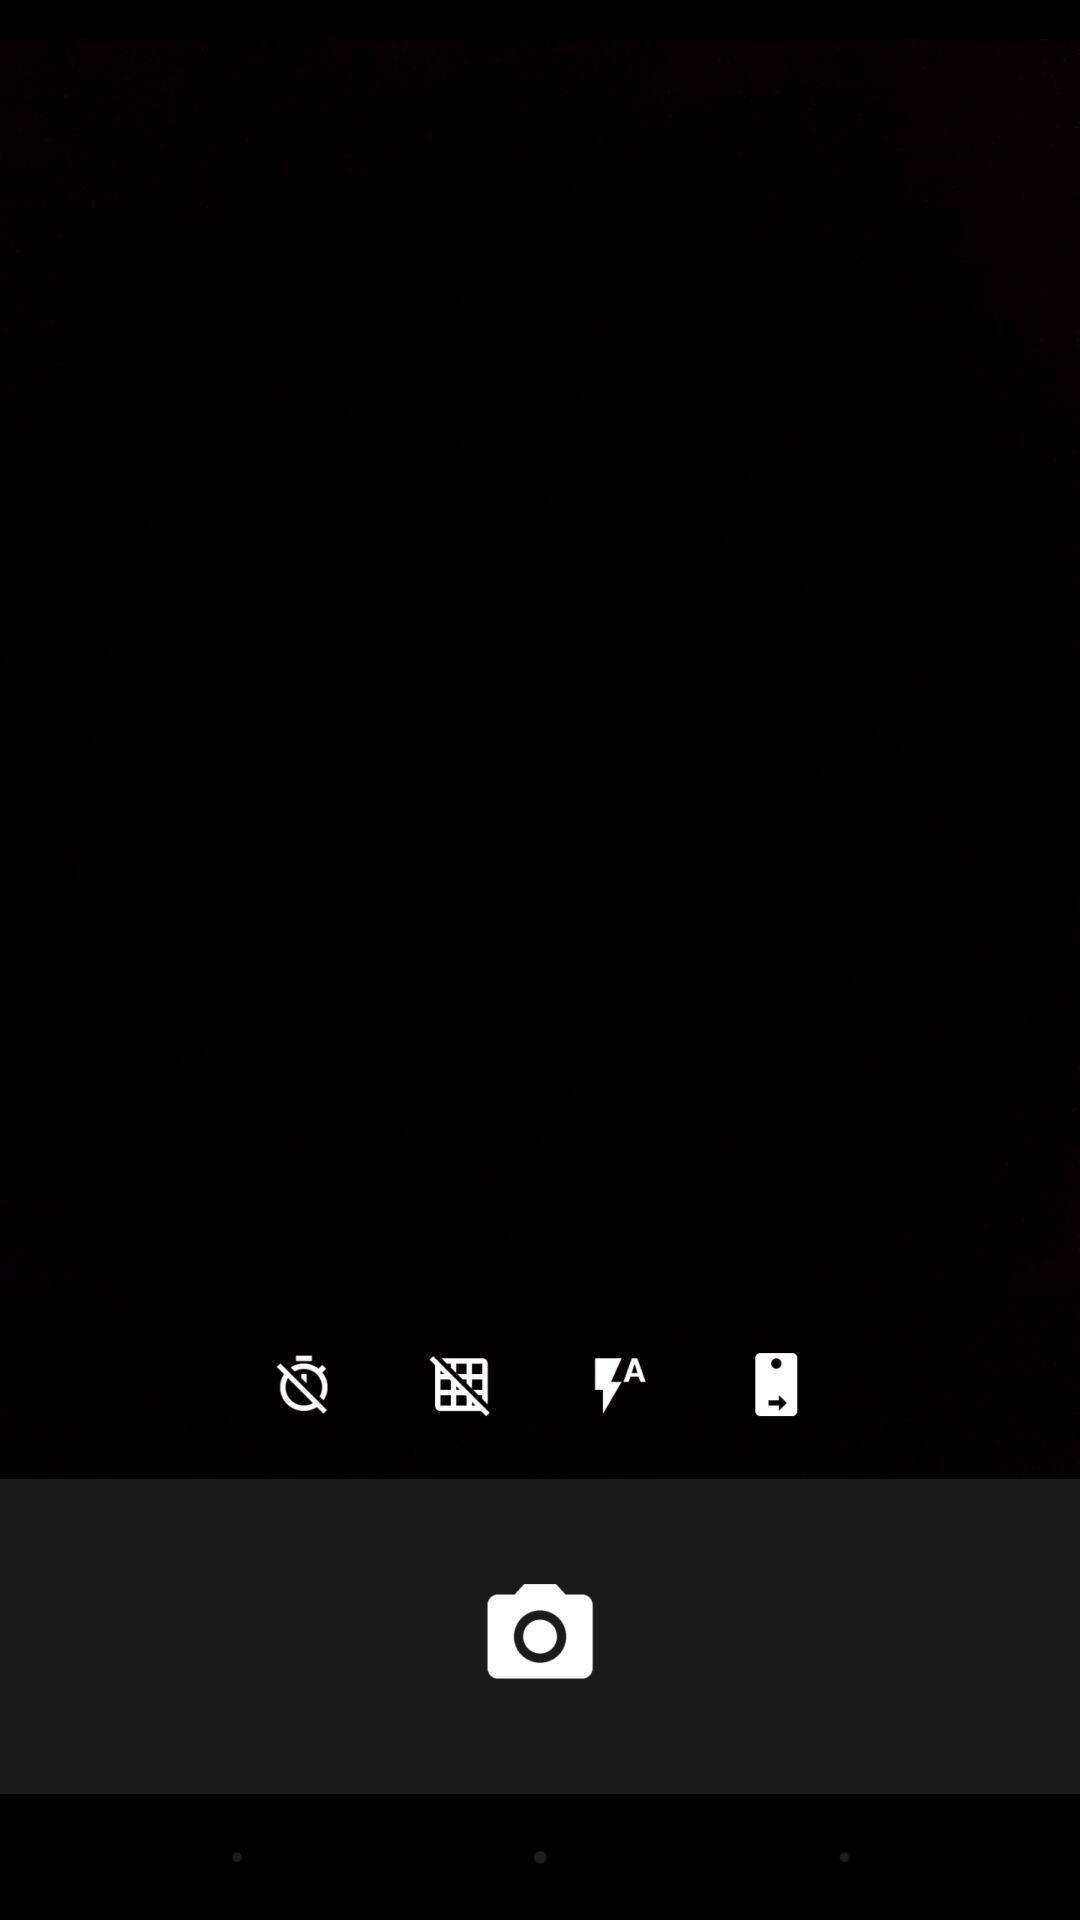Provide a description of this screenshot. Page showing blank camera screen. 